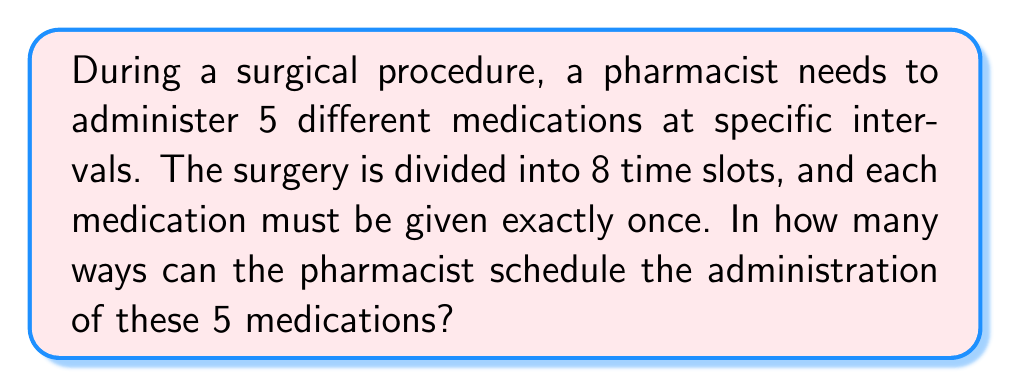Give your solution to this math problem. Let's approach this step-by-step:

1) We have 5 medications to be administered in 8 time slots. This is equivalent to choosing 5 slots out of 8 to place the medications.

2) The order of selecting these 5 slots matters because each medication is distinct and must be given at a specific time.

3) This scenario can be modeled as a permutation problem. Specifically, we are looking for the number of ways to arrange 5 items (medications) in 8 positions (time slots).

4) The formula for this type of permutation is:

   $$P(n,r) = \frac{n!}{(n-r)!}$$

   Where $n$ is the total number of positions (8 time slots) and $r$ is the number of items to be arranged (5 medications).

5) Plugging in our values:

   $$P(8,5) = \frac{8!}{(8-5)!} = \frac{8!}{3!}$$

6) Expanding this:

   $$\frac{8 \times 7 \times 6 \times 5 \times 4 \times 3!}{3!}$$

7) The 3! cancels out in the numerator and denominator:

   $$8 \times 7 \times 6 \times 5 \times 4 = 6720$$

Therefore, there are 6720 possible ways to schedule the administration of these 5 medications during the 8 time slots of the surgery.
Answer: 6720 